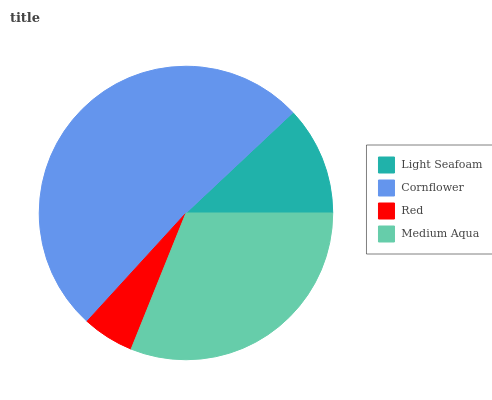Is Red the minimum?
Answer yes or no. Yes. Is Cornflower the maximum?
Answer yes or no. Yes. Is Cornflower the minimum?
Answer yes or no. No. Is Red the maximum?
Answer yes or no. No. Is Cornflower greater than Red?
Answer yes or no. Yes. Is Red less than Cornflower?
Answer yes or no. Yes. Is Red greater than Cornflower?
Answer yes or no. No. Is Cornflower less than Red?
Answer yes or no. No. Is Medium Aqua the high median?
Answer yes or no. Yes. Is Light Seafoam the low median?
Answer yes or no. Yes. Is Cornflower the high median?
Answer yes or no. No. Is Red the low median?
Answer yes or no. No. 